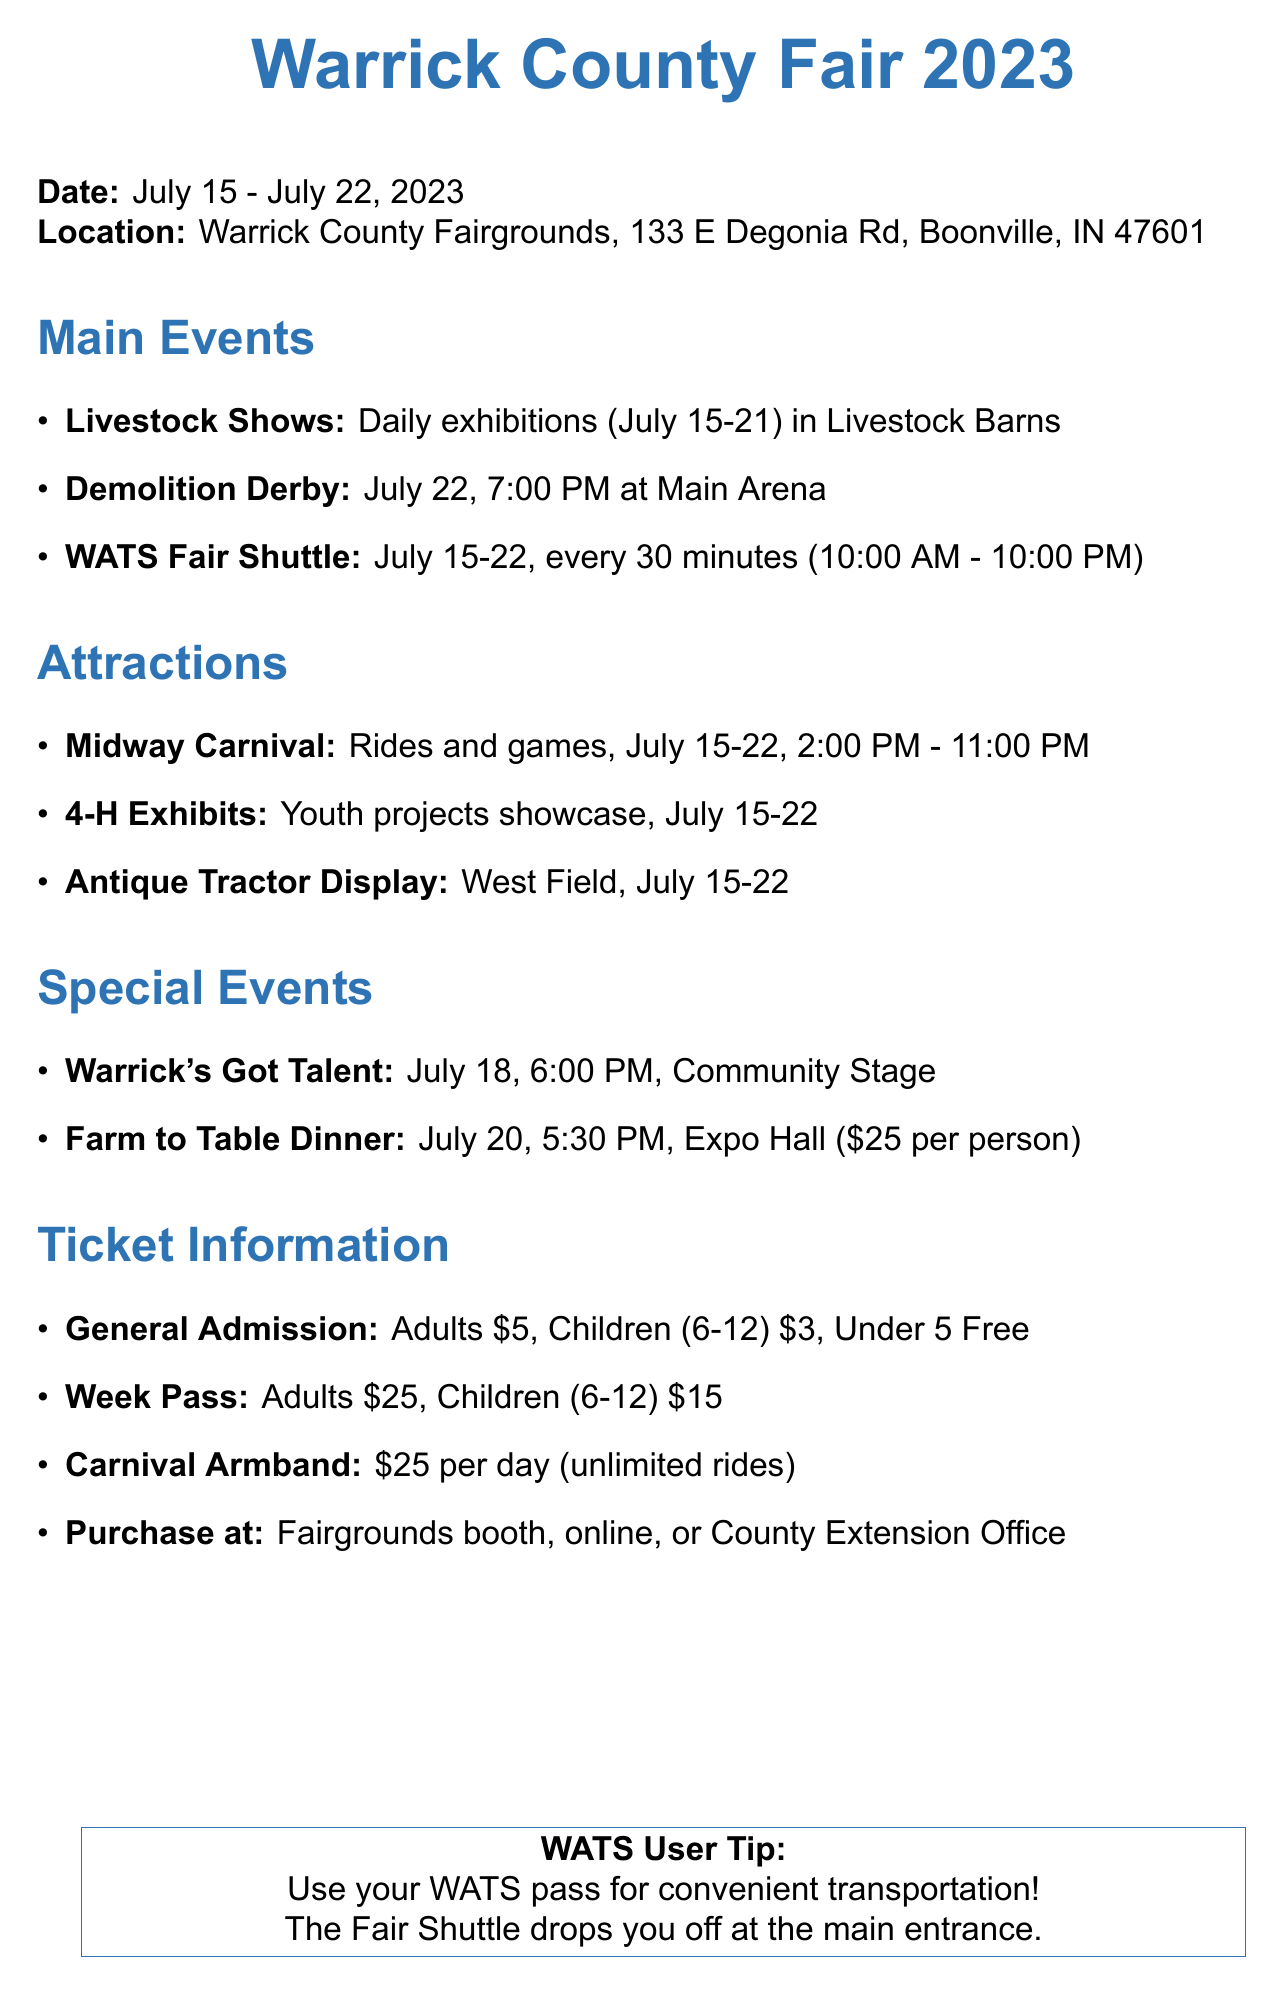What are the fair dates? The fair dates are specified in the document as July 15 to July 22, 2023.
Answer: July 15 - July 22, 2023 Where will the Demolition Derby take place? The location for the Demolition Derby is mentioned explicitly in the document.
Answer: Main Arena What is the ticket price for children aged 6-12? The document lists various ticket prices, including the specific price for children aged 6-12.
Answer: $3 When is the Farm to Table Dinner scheduled? The document provides the specific date for the Farm to Table Dinner as part of the special events.
Answer: July 20 How often does the WATS Fair Shuttle run? The frequency of the WATS Fair Shuttle is stated in the document, which indicates how often it operates.
Answer: Every 30 minutes What type of operator runs the Midway Carnival? The document identifies the operator responsible for the Midway Carnival.
Answer: Poor Jack Amusements What day does "Warrick's Got Talent" occur? The specific day for the talent competition is included in the special events section of the document.
Answer: July 18 What is the ticket price for a weekly admission for adults? The document specifies the cost of a week pass for adults.
Answer: $25 